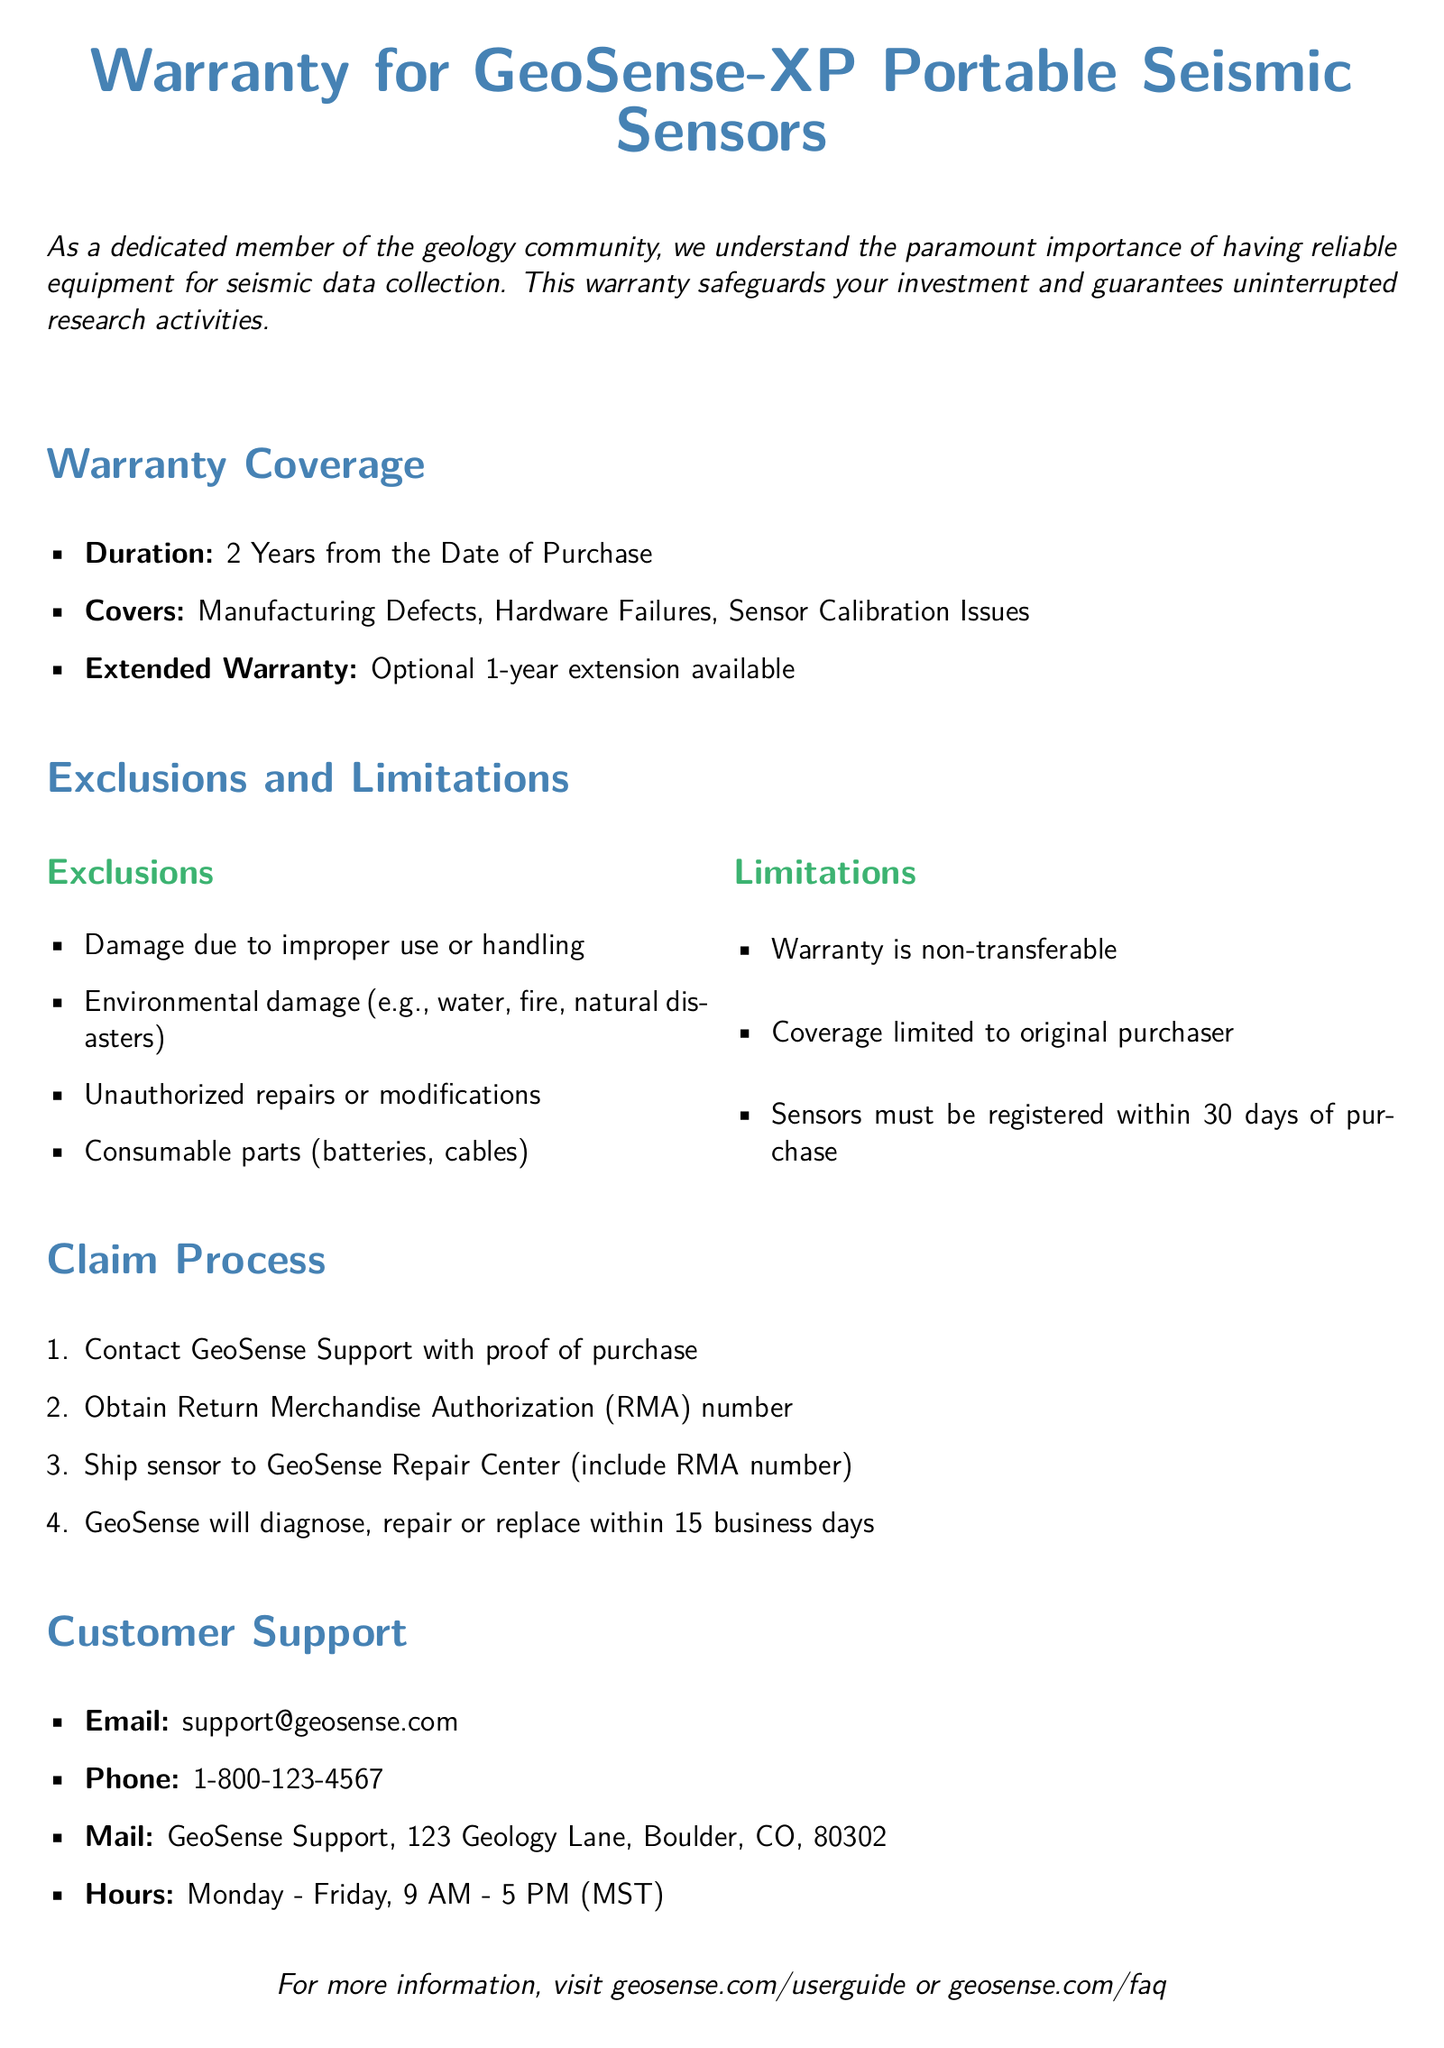what is the warranty duration for GeoSense-XP Portable Seismic Sensors? The warranty duration is specified as the period from the date of purchase, which is 2 years.
Answer: 2 Years what issues are covered under the warranty? The document lists manufacturing defects, hardware failures, and sensor calibration issues as covered items.
Answer: Manufacturing Defects, Hardware Failures, Sensor Calibration Issues is there an option for extending the warranty? The document mentions the possibility of extending the warranty for an additional period beyond the original coverage.
Answer: Optional 1-year extension available what is one type of damage excluded from the warranty? The document specifies that damage due to improper use or handling is one of the exclusions.
Answer: Damage due to improper use or handling how long do customers have to register their sensors for warranty coverage? The document states that sensors must be registered within a specific time frame after purchase to be covered.
Answer: 30 days who should customers contact for warranty claims? The document indicates that customers need to reach out to a specific support service for warranty-related issues.
Answer: GeoSense Support how quickly will GeoSense respond to a warranty claim? The document describes the timeframe in which the company will handle diagnosis or repair of the sensors.
Answer: within 15 business days what is the customer support email address? Customers can find the contact email for support specified in the document.
Answer: support@geosense.com is the warranty transferable to another person? The document states a clear condition regarding the transferability of the warranty.
Answer: non-transferable 